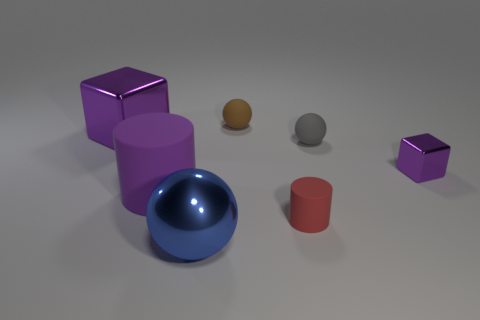Add 1 tiny gray spheres. How many objects exist? 8 Subtract all cylinders. How many objects are left? 5 Add 4 brown metallic cylinders. How many brown metallic cylinders exist? 4 Subtract 0 green blocks. How many objects are left? 7 Subtract all small blocks. Subtract all purple cylinders. How many objects are left? 5 Add 1 tiny gray rubber balls. How many tiny gray rubber balls are left? 2 